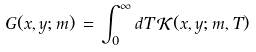Convert formula to latex. <formula><loc_0><loc_0><loc_500><loc_500>G ( x , y ; m ) \, = \, \int _ { 0 } ^ { \infty } d T \, { \mathcal { K } } ( x , y ; m , T )</formula> 